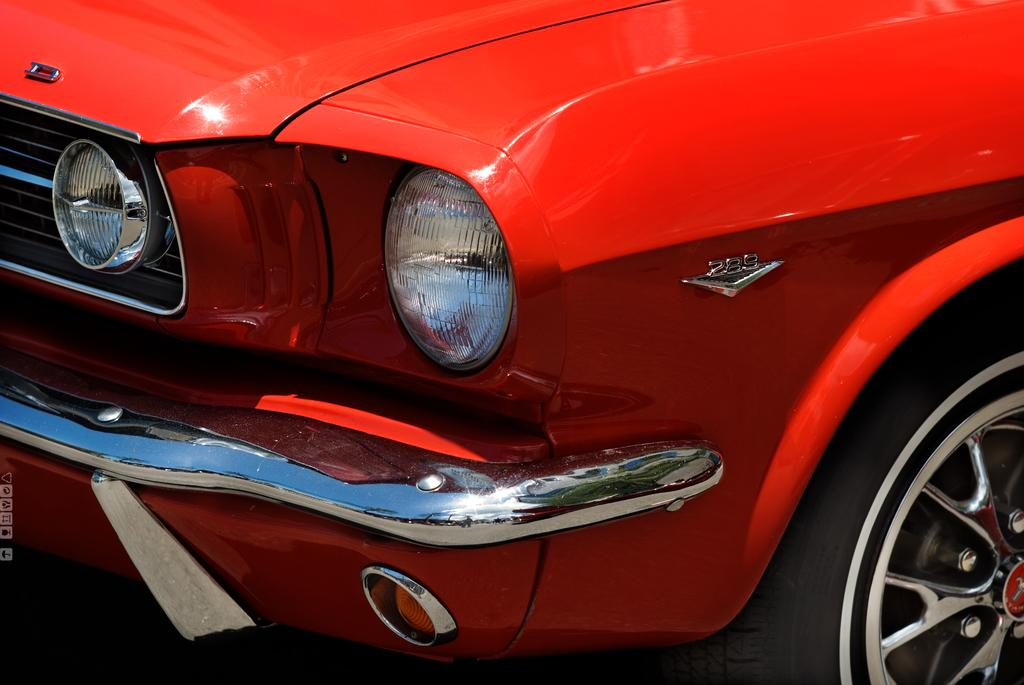What type of vehicle is in the image? There is a red color vehicle in the image. What specific feature does the vehicle have? The vehicle has lights. What is a common component of vehicles? The vehicle has a wheel. What type of class does the carriage belong to in the image? There is no carriage present in the image; it features a red color vehicle. What is the range of the vehicle in the image? The provided facts do not mention any information about the range of the vehicle, so it cannot be determined from the image. 